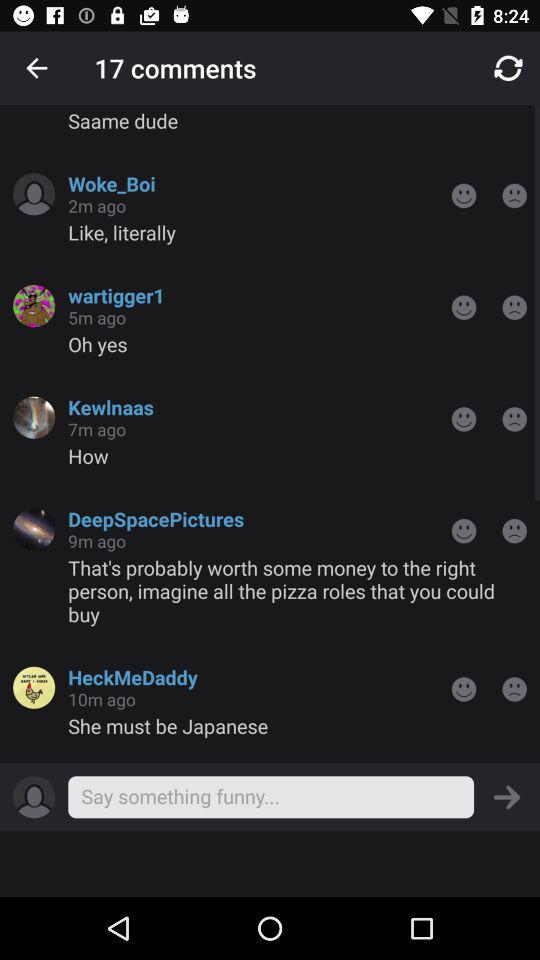How many comments are there in this thread?
Answer the question using a single word or phrase. 17 